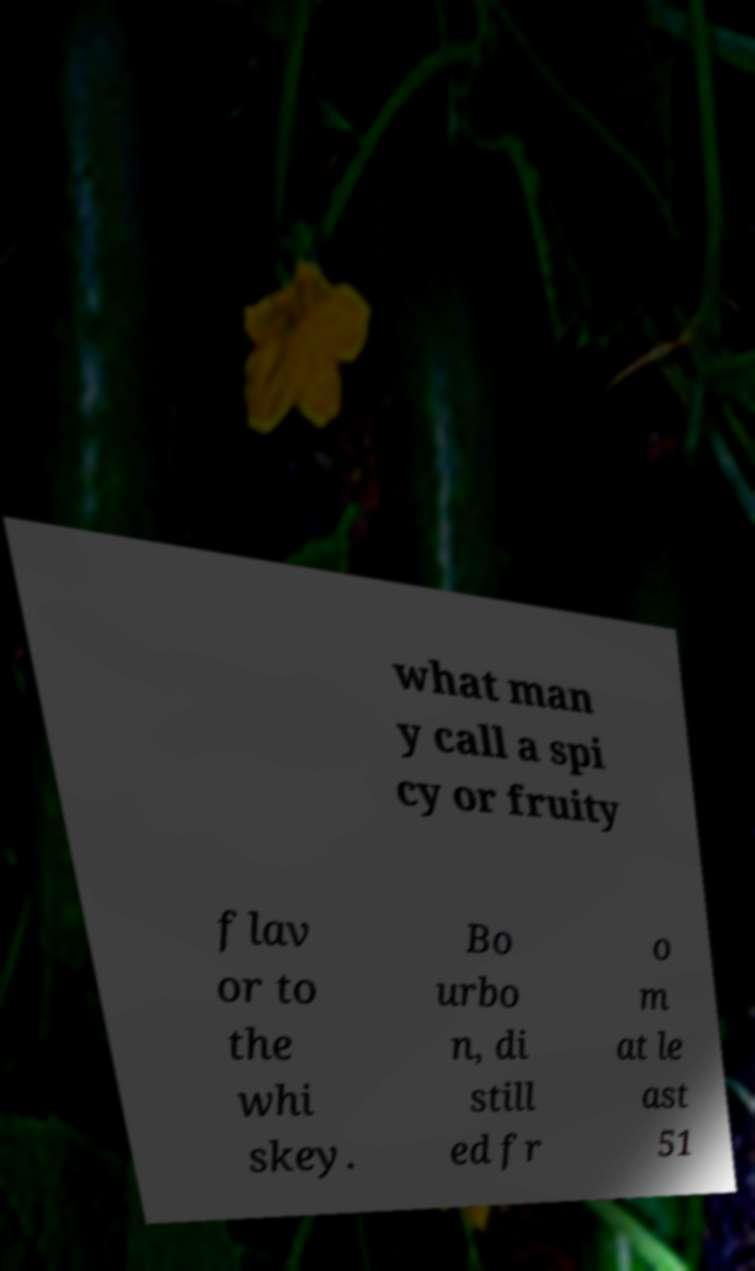Could you assist in decoding the text presented in this image and type it out clearly? what man y call a spi cy or fruity flav or to the whi skey. Bo urbo n, di still ed fr o m at le ast 51 